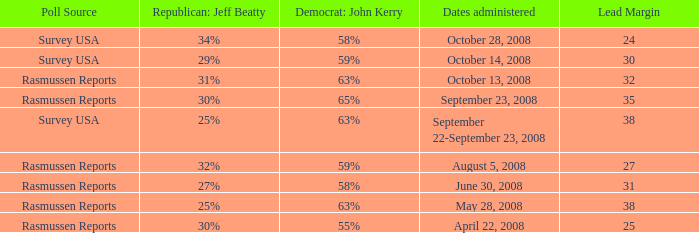What is the maximum lead margin on august 5, 2008? 27.0. 